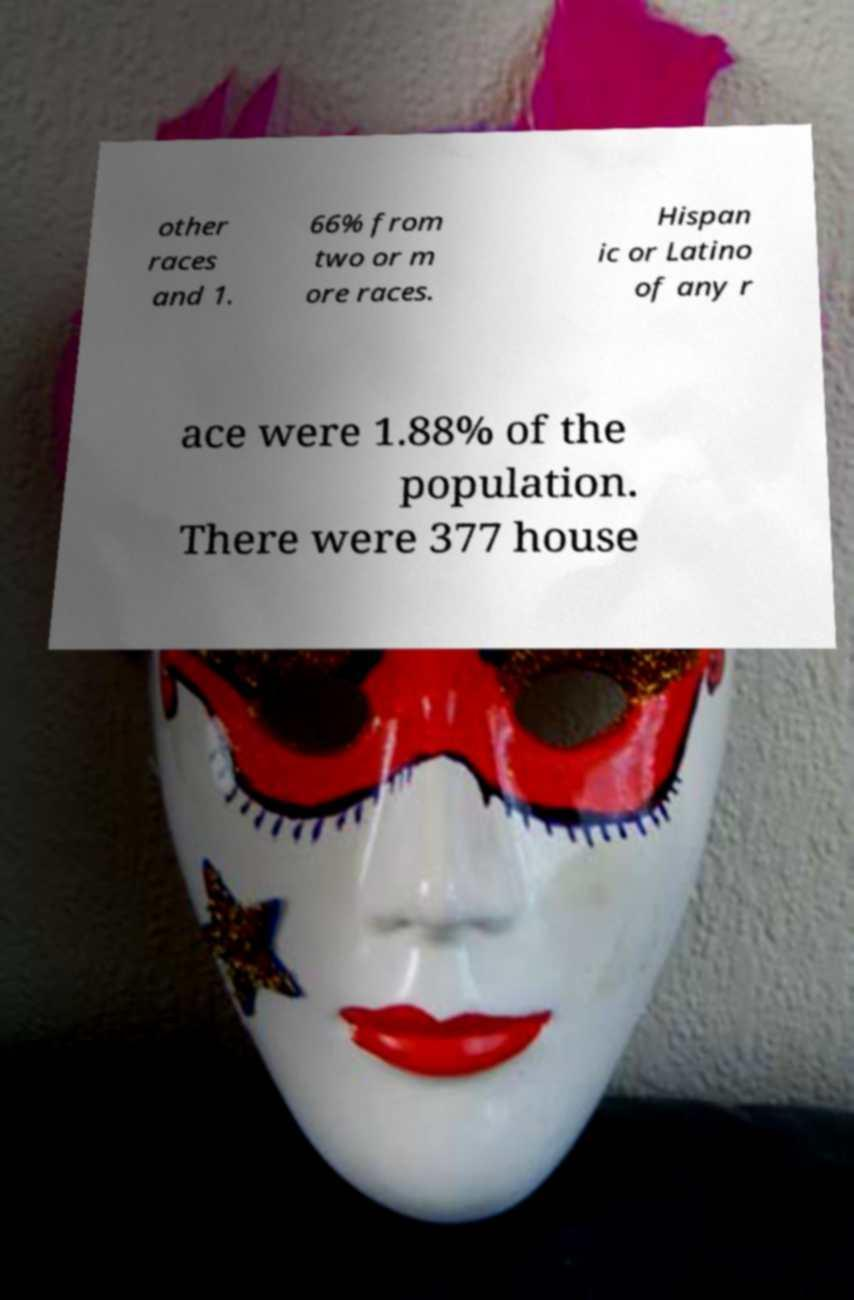Please identify and transcribe the text found in this image. other races and 1. 66% from two or m ore races. Hispan ic or Latino of any r ace were 1.88% of the population. There were 377 house 